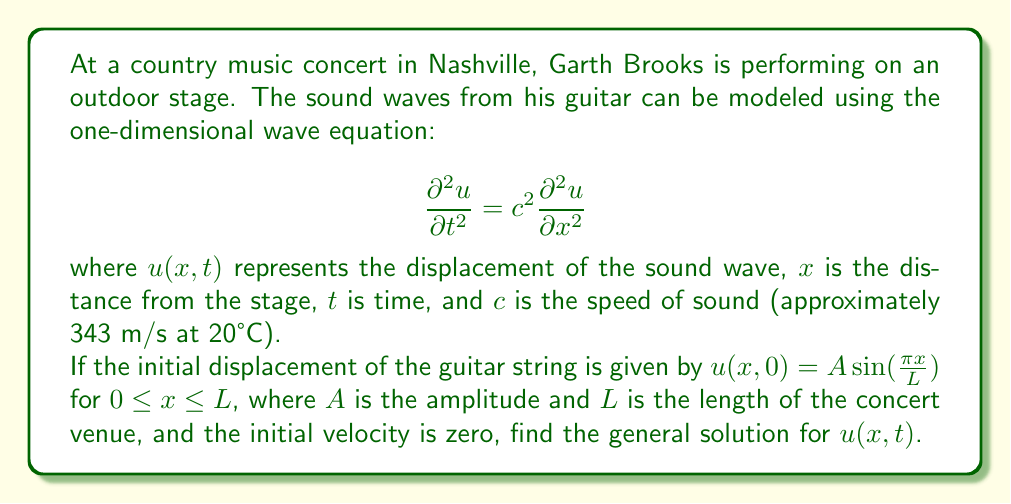Give your solution to this math problem. To solve this problem, we'll use the method of separation of variables:

1) Assume the solution has the form $u(x,t) = X(x)T(t)$.

2) Substituting this into the wave equation:

   $$X(x)T''(t) = c^2X''(x)T(t)$$

3) Dividing both sides by $X(x)T(t)$:

   $$\frac{T''(t)}{T(t)} = c^2\frac{X''(x)}{X(x)} = -\lambda^2$$

   where $-\lambda^2$ is a separation constant.

4) This gives us two ordinary differential equations:
   
   $$T''(t) + \lambda^2c^2T(t) = 0$$
   $$X''(x) + \lambda^2X(x) = 0$$

5) The general solutions to these equations are:
   
   $$T(t) = a\cos(\lambda ct) + b\sin(\lambda ct)$$
   $$X(x) = d\cos(\lambda x) + e\sin(\lambda x)$$

6) The initial conditions give us:
   
   $u(x,0) = A \sin(\frac{\pi x}{L})$, so $\lambda = \frac{\pi}{L}$
   
   $\frac{\partial u}{\partial t}(x,0) = 0$, so $b = 0$

7) Therefore, the solution has the form:

   $$u(x,t) = A \sin(\frac{\pi x}{L})\cos(\frac{\pi ct}{L})$$

This satisfies the initial conditions and the wave equation.
Answer: The general solution for $u(x,t)$ is:

$$u(x,t) = A \sin(\frac{\pi x}{L})\cos(\frac{\pi ct}{L})$$

where $A$ is the amplitude, $L$ is the length of the concert venue, $c$ is the speed of sound, $x$ is the distance from the stage, and $t$ is time. 